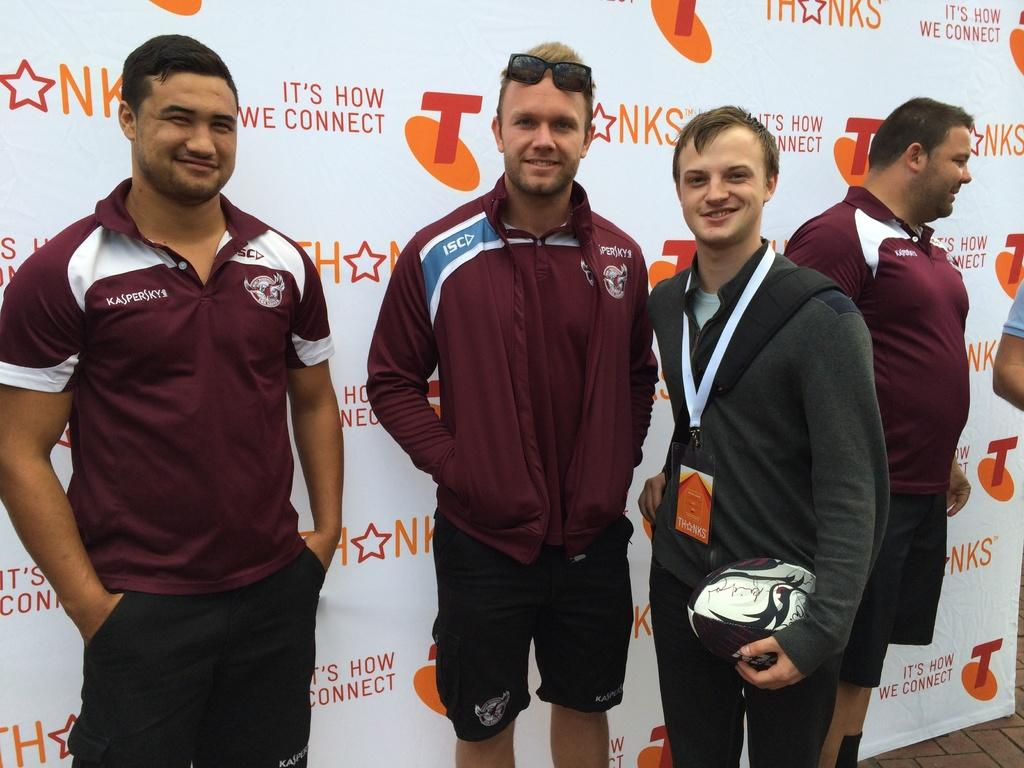Provide a one-sentence caption for the provided image. The people are standing in front of a panner that says NKS. 